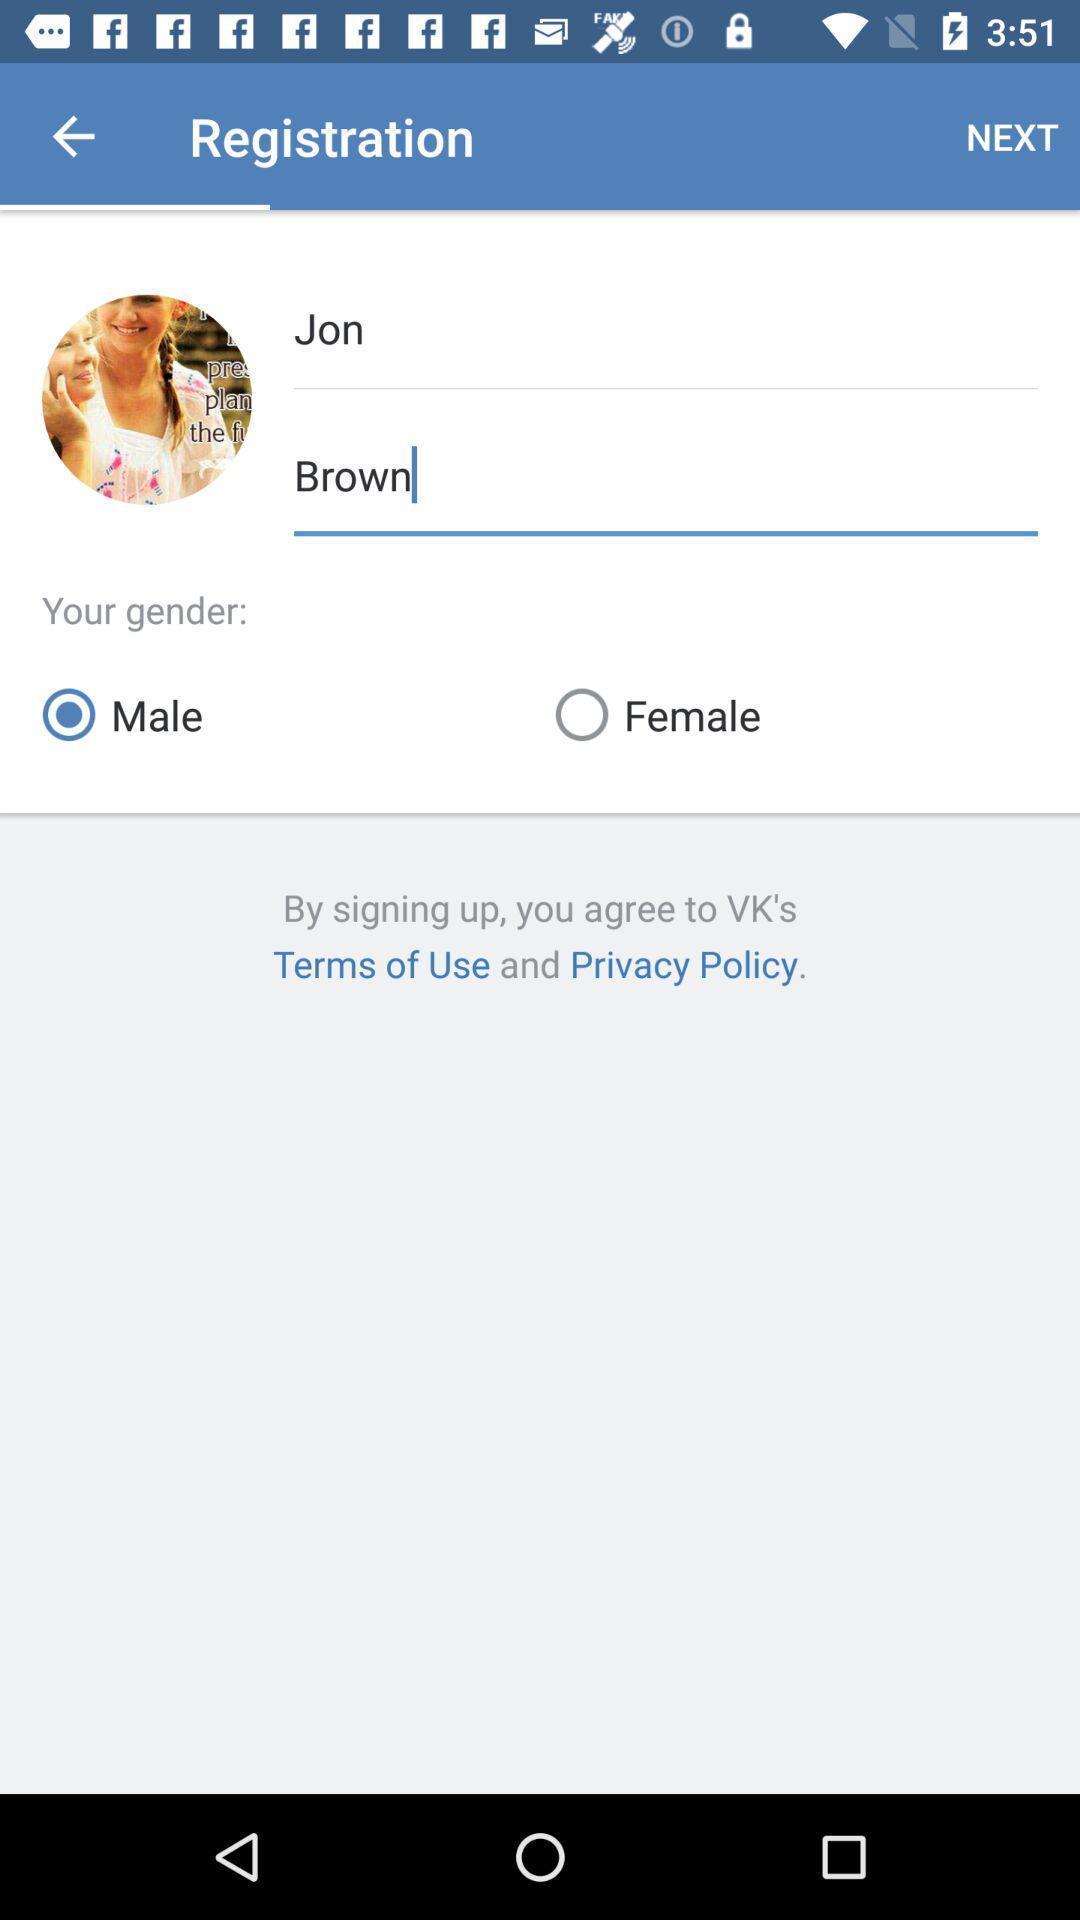What details can you identify in this image? Sign in page of a dating app. 